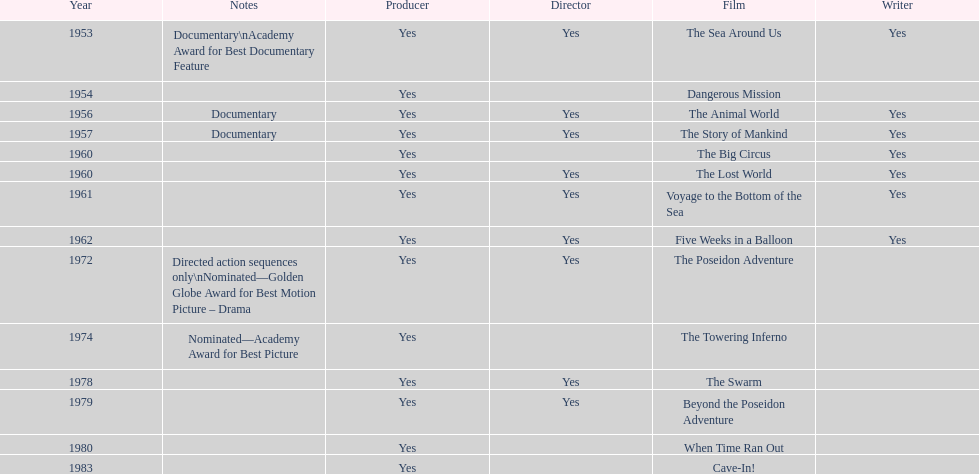How many films did irwin allen direct, produce and write? 6. I'm looking to parse the entire table for insights. Could you assist me with that? {'header': ['Year', 'Notes', 'Producer', 'Director', 'Film', 'Writer'], 'rows': [['1953', 'Documentary\\nAcademy Award for Best Documentary Feature', 'Yes', 'Yes', 'The Sea Around Us', 'Yes'], ['1954', '', 'Yes', '', 'Dangerous Mission', ''], ['1956', 'Documentary', 'Yes', 'Yes', 'The Animal World', 'Yes'], ['1957', 'Documentary', 'Yes', 'Yes', 'The Story of Mankind', 'Yes'], ['1960', '', 'Yes', '', 'The Big Circus', 'Yes'], ['1960', '', 'Yes', 'Yes', 'The Lost World', 'Yes'], ['1961', '', 'Yes', 'Yes', 'Voyage to the Bottom of the Sea', 'Yes'], ['1962', '', 'Yes', 'Yes', 'Five Weeks in a Balloon', 'Yes'], ['1972', 'Directed action sequences only\\nNominated—Golden Globe Award for Best Motion Picture – Drama', 'Yes', 'Yes', 'The Poseidon Adventure', ''], ['1974', 'Nominated—Academy Award for Best Picture', 'Yes', '', 'The Towering Inferno', ''], ['1978', '', 'Yes', 'Yes', 'The Swarm', ''], ['1979', '', 'Yes', 'Yes', 'Beyond the Poseidon Adventure', ''], ['1980', '', 'Yes', '', 'When Time Ran Out', ''], ['1983', '', 'Yes', '', 'Cave-In!', '']]} 